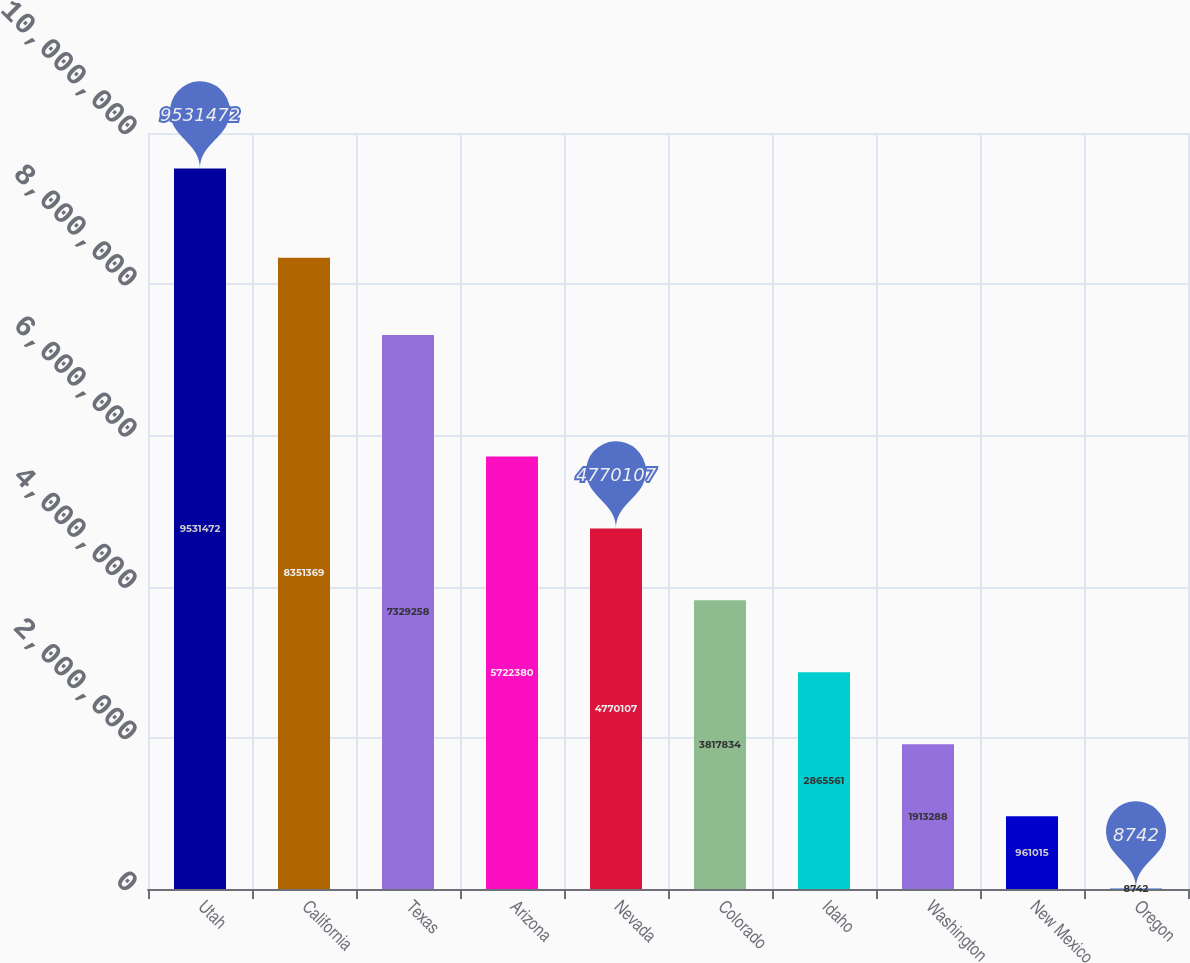Convert chart to OTSL. <chart><loc_0><loc_0><loc_500><loc_500><bar_chart><fcel>Utah<fcel>California<fcel>Texas<fcel>Arizona<fcel>Nevada<fcel>Colorado<fcel>Idaho<fcel>Washington<fcel>New Mexico<fcel>Oregon<nl><fcel>9.53147e+06<fcel>8.35137e+06<fcel>7.32926e+06<fcel>5.72238e+06<fcel>4.77011e+06<fcel>3.81783e+06<fcel>2.86556e+06<fcel>1.91329e+06<fcel>961015<fcel>8742<nl></chart> 